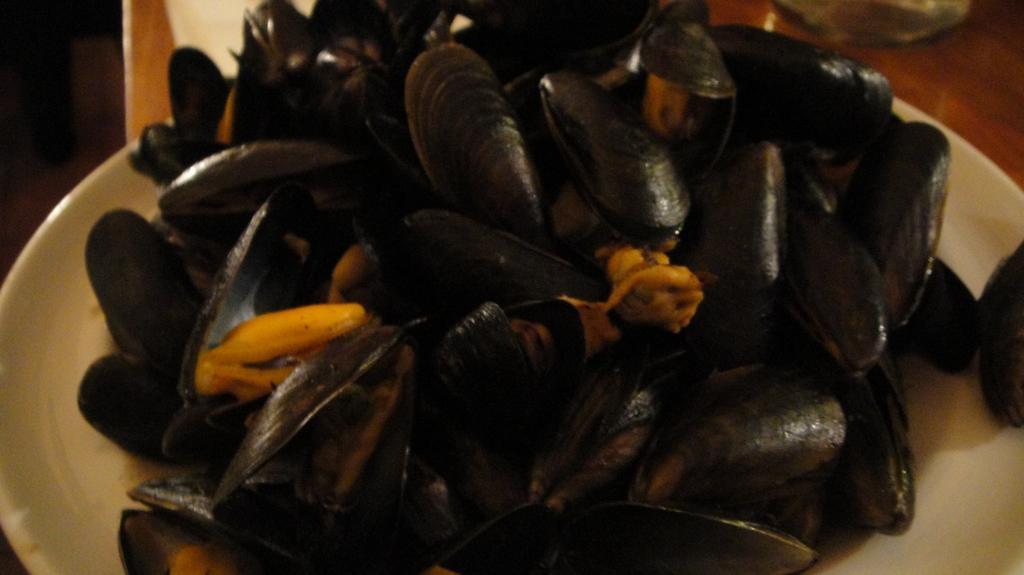Please provide a concise description of this image. There is a white plate. On that there are black color shells. 